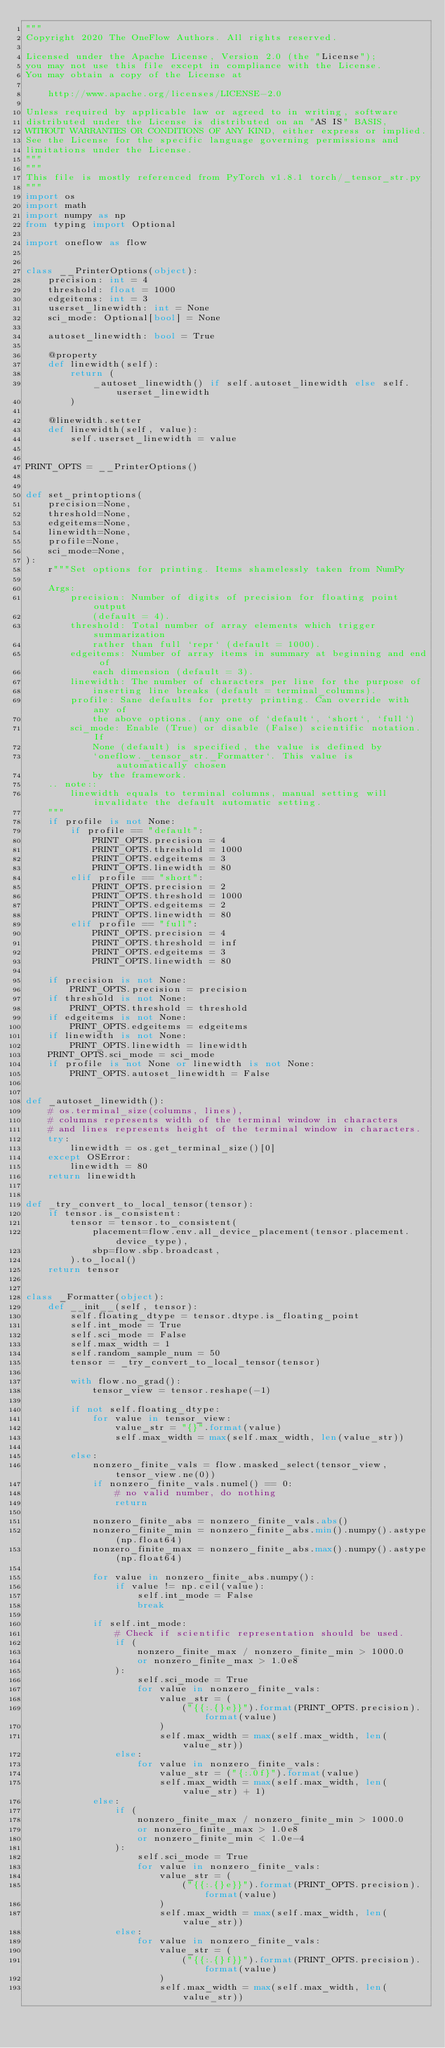<code> <loc_0><loc_0><loc_500><loc_500><_Python_>"""
Copyright 2020 The OneFlow Authors. All rights reserved.

Licensed under the Apache License, Version 2.0 (the "License");
you may not use this file except in compliance with the License.
You may obtain a copy of the License at

    http://www.apache.org/licenses/LICENSE-2.0

Unless required by applicable law or agreed to in writing, software
distributed under the License is distributed on an "AS IS" BASIS,
WITHOUT WARRANTIES OR CONDITIONS OF ANY KIND, either express or implied.
See the License for the specific language governing permissions and
limitations under the License.
"""
"""
This file is mostly referenced from PyTorch v1.8.1 torch/_tensor_str.py
"""
import os
import math
import numpy as np
from typing import Optional

import oneflow as flow


class __PrinterOptions(object):
    precision: int = 4
    threshold: float = 1000
    edgeitems: int = 3
    userset_linewidth: int = None
    sci_mode: Optional[bool] = None

    autoset_linewidth: bool = True

    @property
    def linewidth(self):
        return (
            _autoset_linewidth() if self.autoset_linewidth else self.userset_linewidth
        )

    @linewidth.setter
    def linewidth(self, value):
        self.userset_linewidth = value


PRINT_OPTS = __PrinterOptions()


def set_printoptions(
    precision=None,
    threshold=None,
    edgeitems=None,
    linewidth=None,
    profile=None,
    sci_mode=None,
):
    r"""Set options for printing. Items shamelessly taken from NumPy

    Args:
        precision: Number of digits of precision for floating point output
            (default = 4).
        threshold: Total number of array elements which trigger summarization
            rather than full `repr` (default = 1000).
        edgeitems: Number of array items in summary at beginning and end of
            each dimension (default = 3).
        linewidth: The number of characters per line for the purpose of
            inserting line breaks (default = terminal_columns).
        profile: Sane defaults for pretty printing. Can override with any of
            the above options. (any one of `default`, `short`, `full`)
        sci_mode: Enable (True) or disable (False) scientific notation. If
            None (default) is specified, the value is defined by
            `oneflow._tensor_str._Formatter`. This value is automatically chosen
            by the framework.
    .. note::
        linewidth equals to terminal columns, manual setting will invalidate the default automatic setting.
    """
    if profile is not None:
        if profile == "default":
            PRINT_OPTS.precision = 4
            PRINT_OPTS.threshold = 1000
            PRINT_OPTS.edgeitems = 3
            PRINT_OPTS.linewidth = 80
        elif profile == "short":
            PRINT_OPTS.precision = 2
            PRINT_OPTS.threshold = 1000
            PRINT_OPTS.edgeitems = 2
            PRINT_OPTS.linewidth = 80
        elif profile == "full":
            PRINT_OPTS.precision = 4
            PRINT_OPTS.threshold = inf
            PRINT_OPTS.edgeitems = 3
            PRINT_OPTS.linewidth = 80

    if precision is not None:
        PRINT_OPTS.precision = precision
    if threshold is not None:
        PRINT_OPTS.threshold = threshold
    if edgeitems is not None:
        PRINT_OPTS.edgeitems = edgeitems
    if linewidth is not None:
        PRINT_OPTS.linewidth = linewidth
    PRINT_OPTS.sci_mode = sci_mode
    if profile is not None or linewidth is not None:
        PRINT_OPTS.autoset_linewidth = False


def _autoset_linewidth():
    # os.terminal_size(columns, lines),
    # columns represents width of the terminal window in characters
    # and lines represents height of the terminal window in characters.
    try:
        linewidth = os.get_terminal_size()[0]
    except OSError:
        linewidth = 80
    return linewidth


def _try_convert_to_local_tensor(tensor):
    if tensor.is_consistent:
        tensor = tensor.to_consistent(
            placement=flow.env.all_device_placement(tensor.placement.device_type),
            sbp=flow.sbp.broadcast,
        ).to_local()
    return tensor


class _Formatter(object):
    def __init__(self, tensor):
        self.floating_dtype = tensor.dtype.is_floating_point
        self.int_mode = True
        self.sci_mode = False
        self.max_width = 1
        self.random_sample_num = 50
        tensor = _try_convert_to_local_tensor(tensor)

        with flow.no_grad():
            tensor_view = tensor.reshape(-1)

        if not self.floating_dtype:
            for value in tensor_view:
                value_str = "{}".format(value)
                self.max_width = max(self.max_width, len(value_str))

        else:
            nonzero_finite_vals = flow.masked_select(tensor_view, tensor_view.ne(0))
            if nonzero_finite_vals.numel() == 0:
                # no valid number, do nothing
                return

            nonzero_finite_abs = nonzero_finite_vals.abs()
            nonzero_finite_min = nonzero_finite_abs.min().numpy().astype(np.float64)
            nonzero_finite_max = nonzero_finite_abs.max().numpy().astype(np.float64)

            for value in nonzero_finite_abs.numpy():
                if value != np.ceil(value):
                    self.int_mode = False
                    break

            if self.int_mode:
                # Check if scientific representation should be used.
                if (
                    nonzero_finite_max / nonzero_finite_min > 1000.0
                    or nonzero_finite_max > 1.0e8
                ):
                    self.sci_mode = True
                    for value in nonzero_finite_vals:
                        value_str = (
                            ("{{:.{}e}}").format(PRINT_OPTS.precision).format(value)
                        )
                        self.max_width = max(self.max_width, len(value_str))
                else:
                    for value in nonzero_finite_vals:
                        value_str = ("{:.0f}").format(value)
                        self.max_width = max(self.max_width, len(value_str) + 1)
            else:
                if (
                    nonzero_finite_max / nonzero_finite_min > 1000.0
                    or nonzero_finite_max > 1.0e8
                    or nonzero_finite_min < 1.0e-4
                ):
                    self.sci_mode = True
                    for value in nonzero_finite_vals:
                        value_str = (
                            ("{{:.{}e}}").format(PRINT_OPTS.precision).format(value)
                        )
                        self.max_width = max(self.max_width, len(value_str))
                else:
                    for value in nonzero_finite_vals:
                        value_str = (
                            ("{{:.{}f}}").format(PRINT_OPTS.precision).format(value)
                        )
                        self.max_width = max(self.max_width, len(value_str))
</code> 